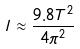Convert formula to latex. <formula><loc_0><loc_0><loc_500><loc_500>l \approx \frac { 9 . 8 T ^ { 2 } } { 4 \pi ^ { 2 } }</formula> 